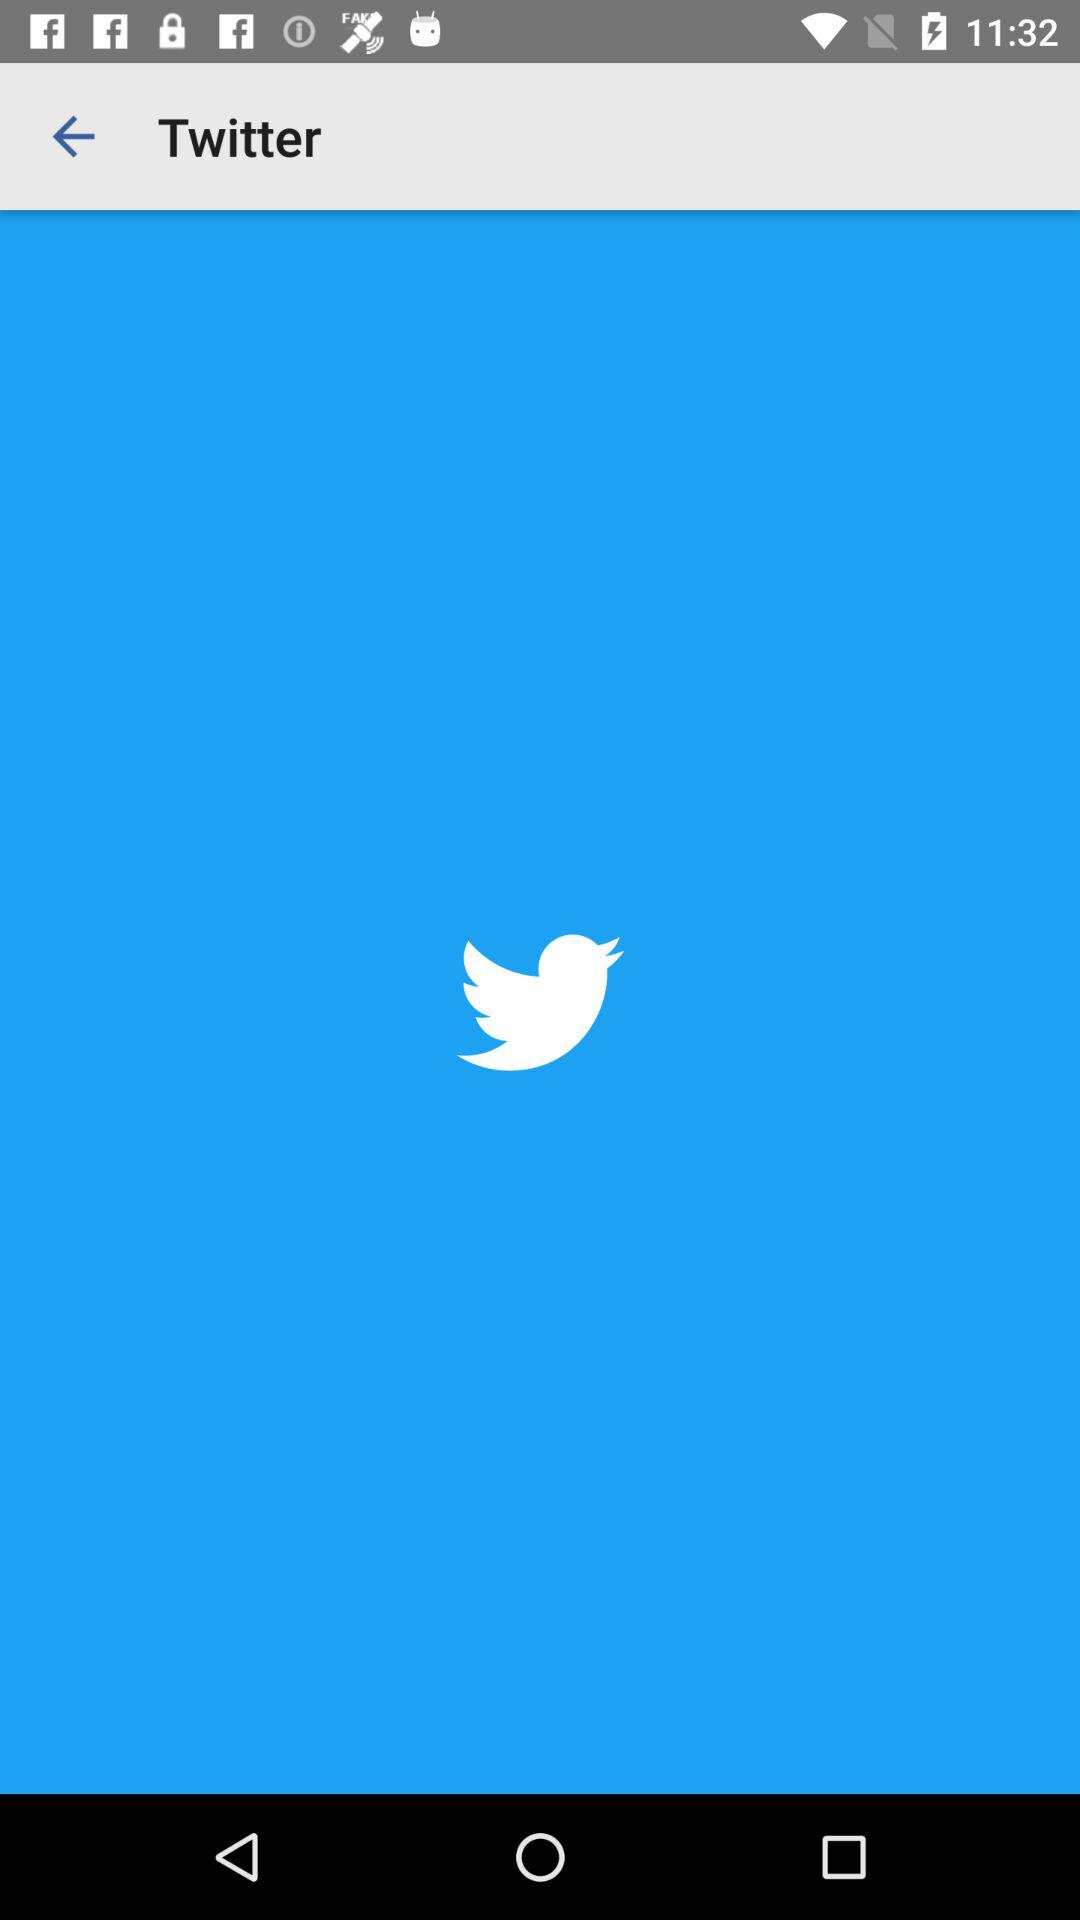What is the application name? The application name is "Twitter". 